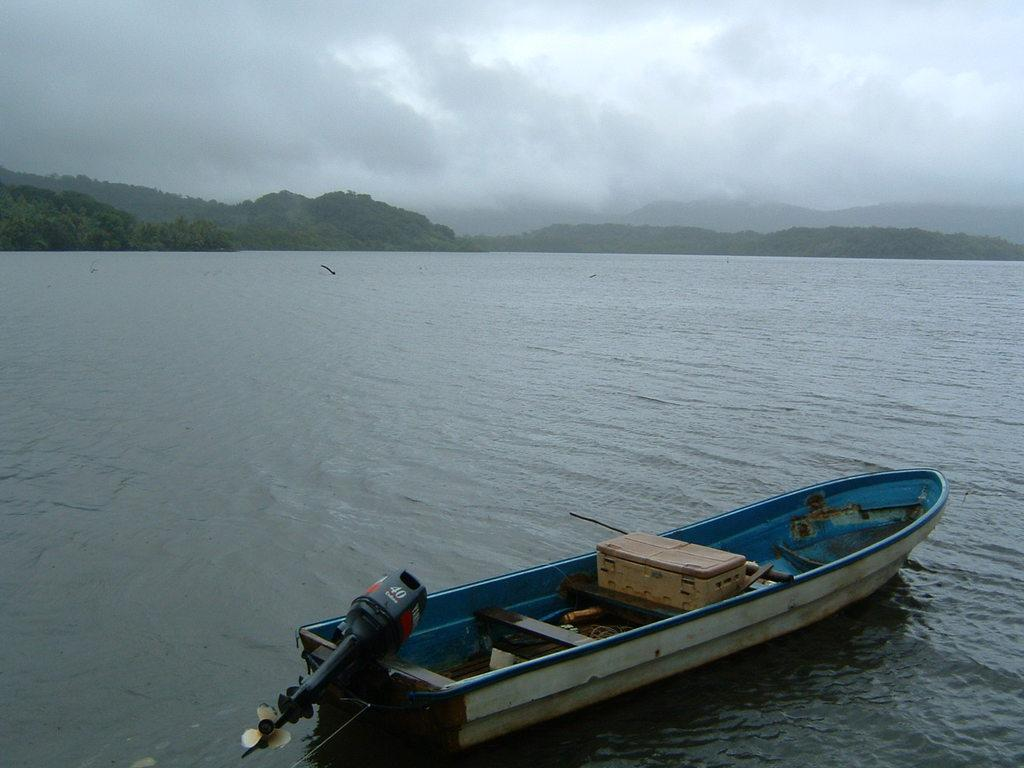What is the main subject of the image? The main subject of the image is a boat. Where is the boat located? The boat is on the water. What type of vegetation can be seen in the image? There are trees in the image. What is visible in the background of the image? There are mountains in the background of the image. What is visible at the top of the image? The sky is visible at the top of the image. How many chairs are placed around the tree in the image? There is no tree or chairs present in the image. What color is the chalk used to draw on the boat? There is no chalk or drawing on the boat in the image. 